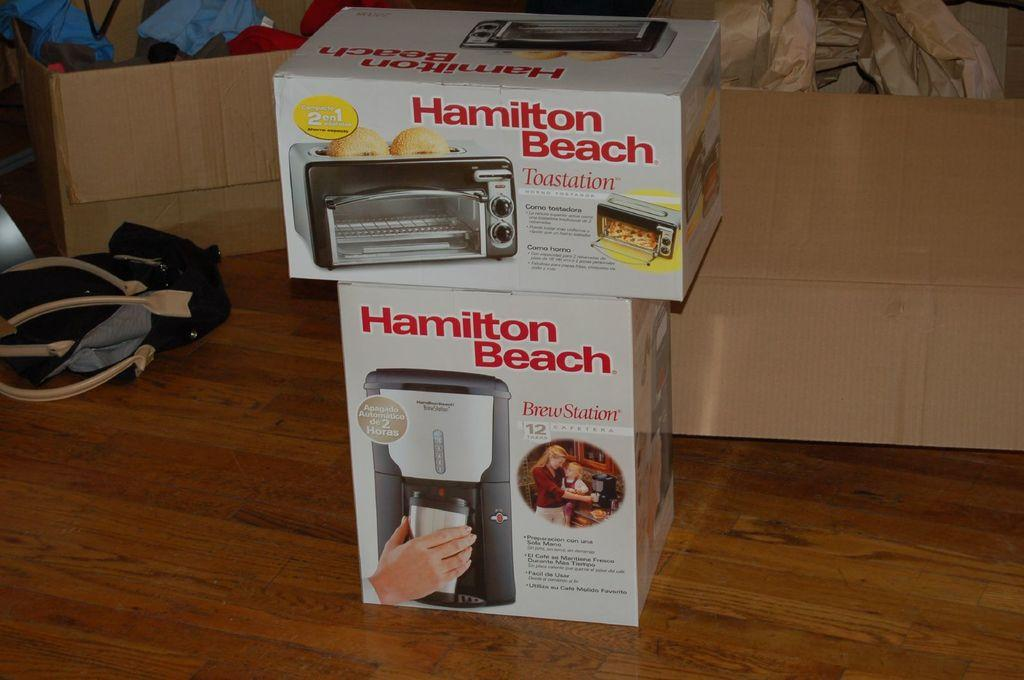<image>
Relay a brief, clear account of the picture shown. A Hamilton Beach Toaster Oven box sits on top of another Hamilton Beach Coffee Maker box. 